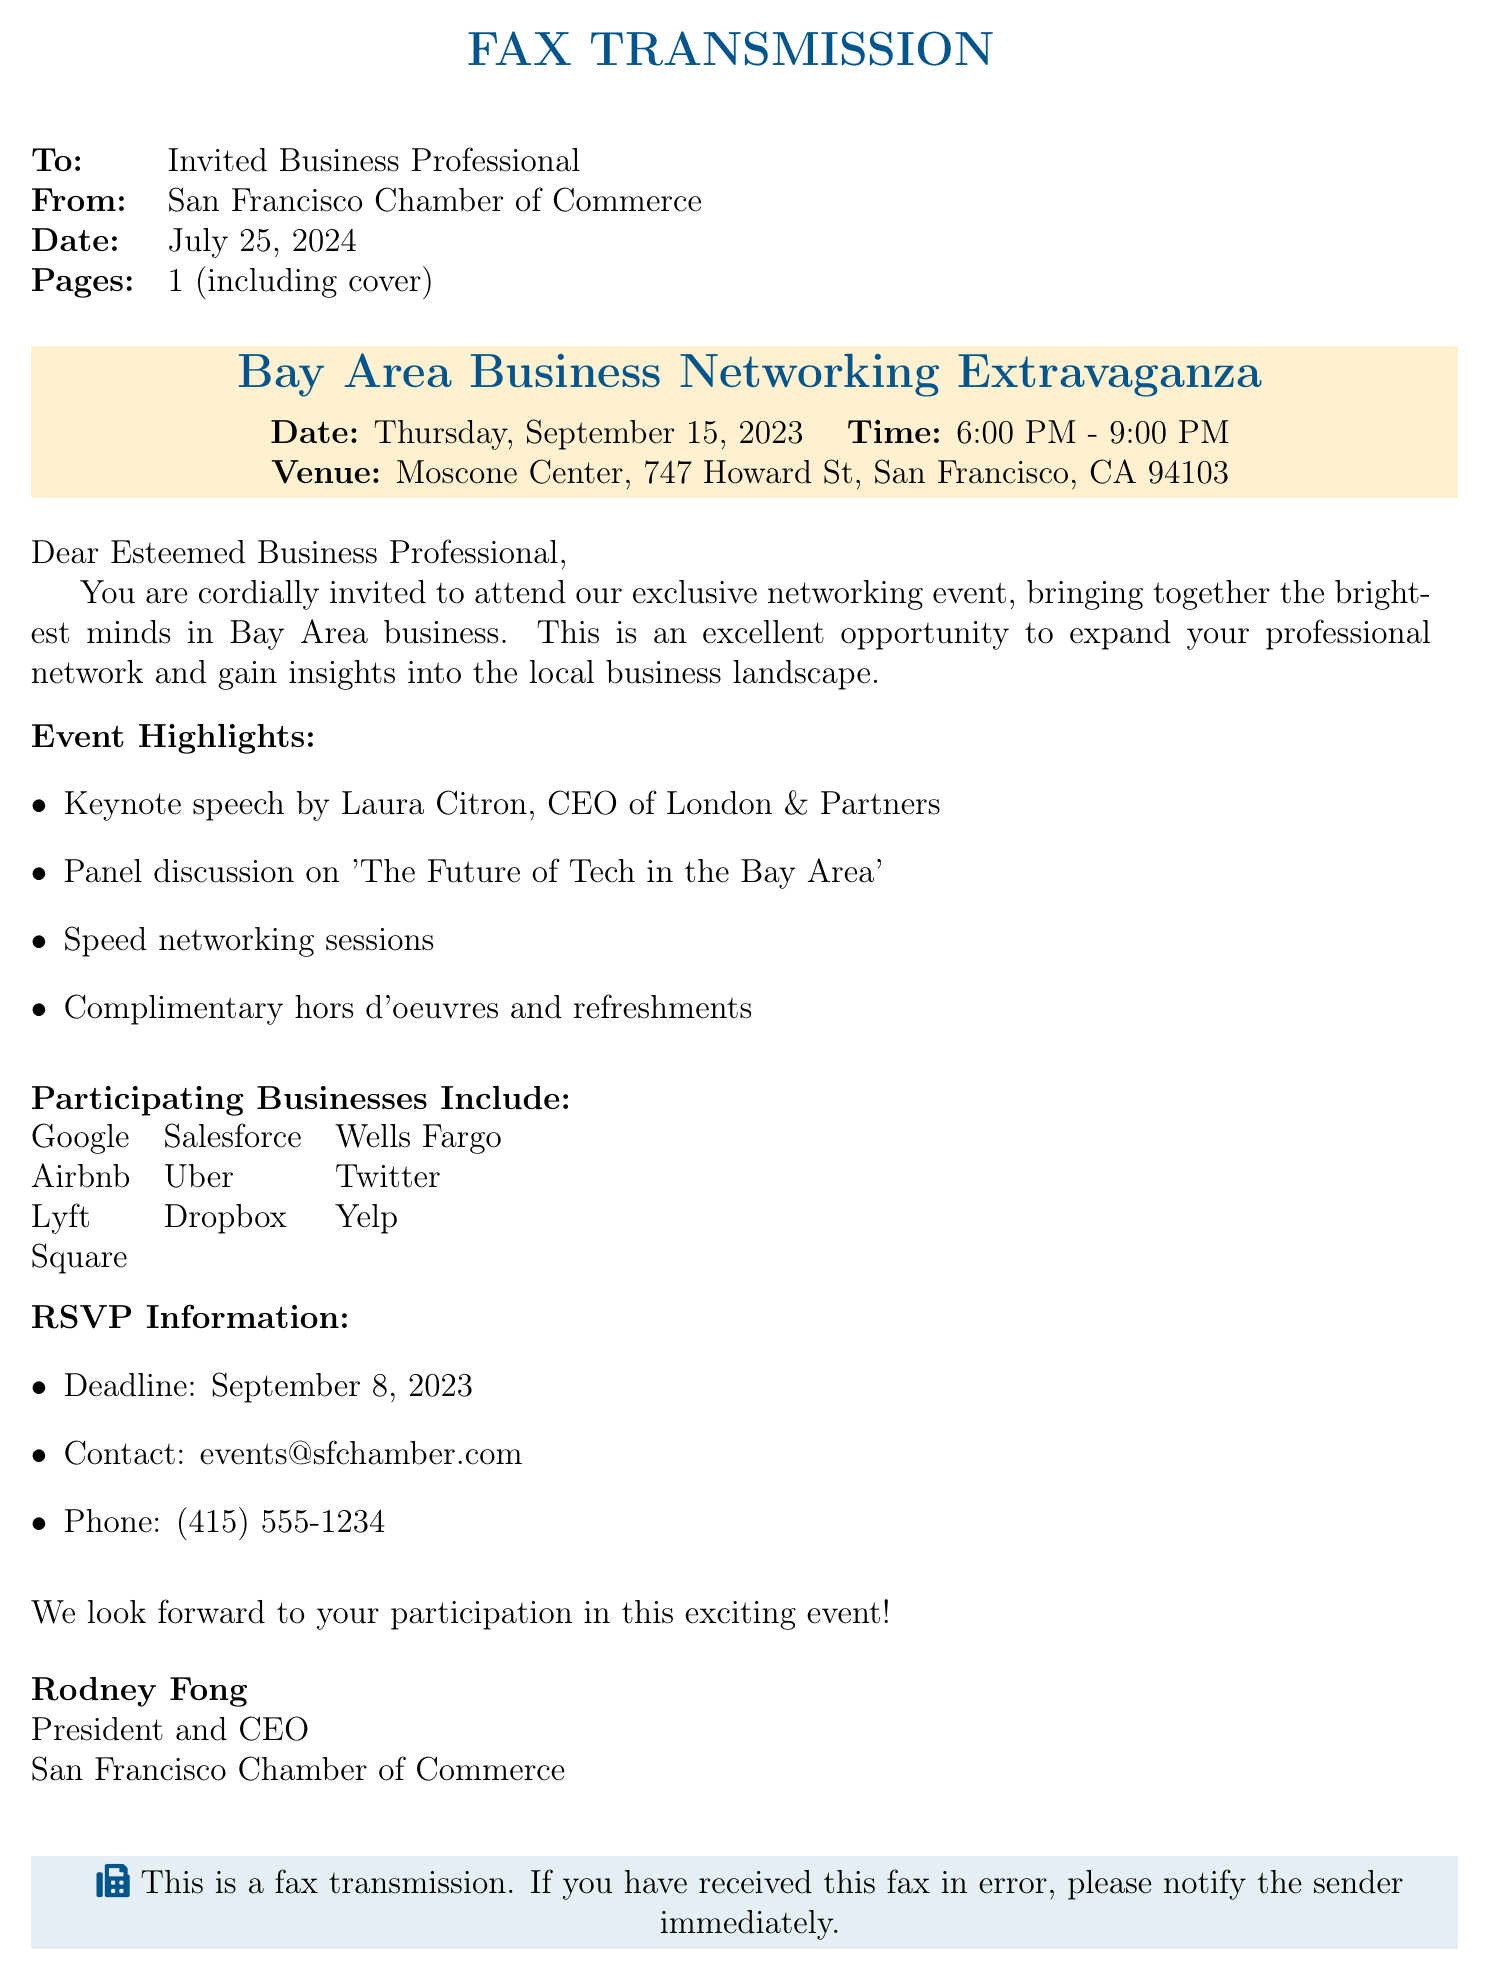What is the name of the event? The event is referred to as the "Bay Area Business Networking Extravaganza" in the document.
Answer: Bay Area Business Networking Extravaganza What is the date of the event? The document specifies that the event will take place on Thursday, September 15, 2023.
Answer: September 15, 2023 Who is the keynote speaker? The document mentions that Laura Citron, CEO of London & Partners, will be giving the keynote speech.
Answer: Laura Citron What time does the event start? The starting time of the event is listed as 6:00 PM.
Answer: 6:00 PM How many participating businesses are listed? The document lists ten participating businesses in total.
Answer: 10 What is the RSVP deadline? The RSVP deadline for the event is mentioned as September 8, 2023.
Answer: September 8, 2023 What type of refreshments will be provided? The document states that there will be "complimentary hors d'oeuvres and refreshments."
Answer: hors d'oeuvres and refreshments What is the contact email for RSVP? The document provides the email as events@sfchamber.com for RSVPs.
Answer: events@sfchamber.com What is the venue of the event? The venue for the event is identified as the Moscone Center in San Francisco.
Answer: Moscone Center 